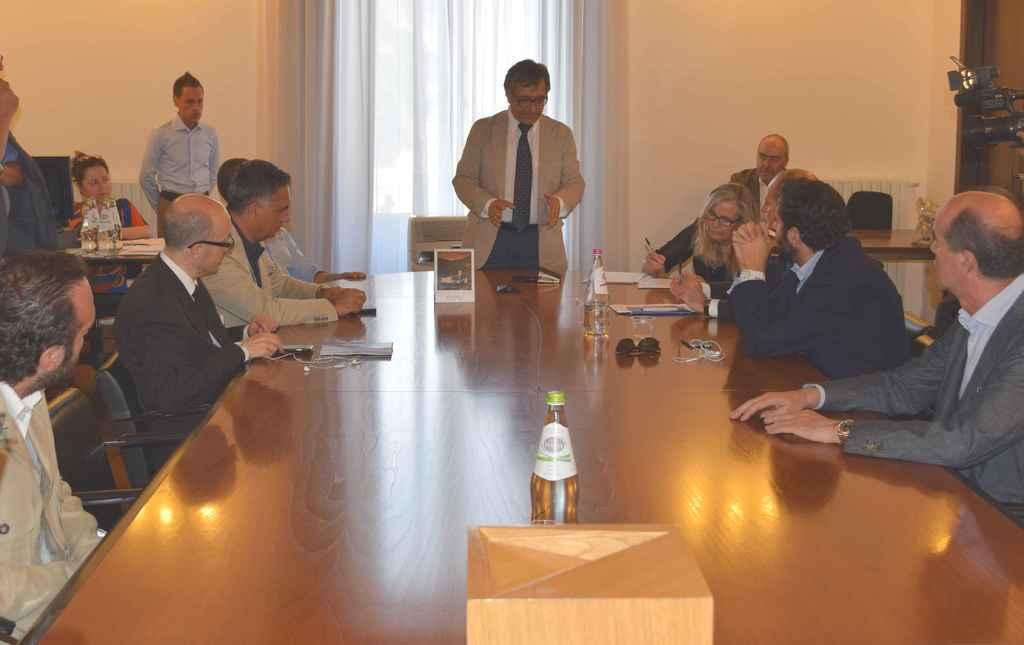Could you give a brief overview of what you see in this image? This picture is clicked inside a room. There are few people sitting on chairs at the table. On the table there is a box, bottles, sunglasses, papers, mobile phones and files. there is another table to the top left corner of the image. On the table there are papers and bottles. To the right corner of the image there is another table and on it there is a sculpture. To the top right corner there is a camera. In the background there is wall and curtain. 